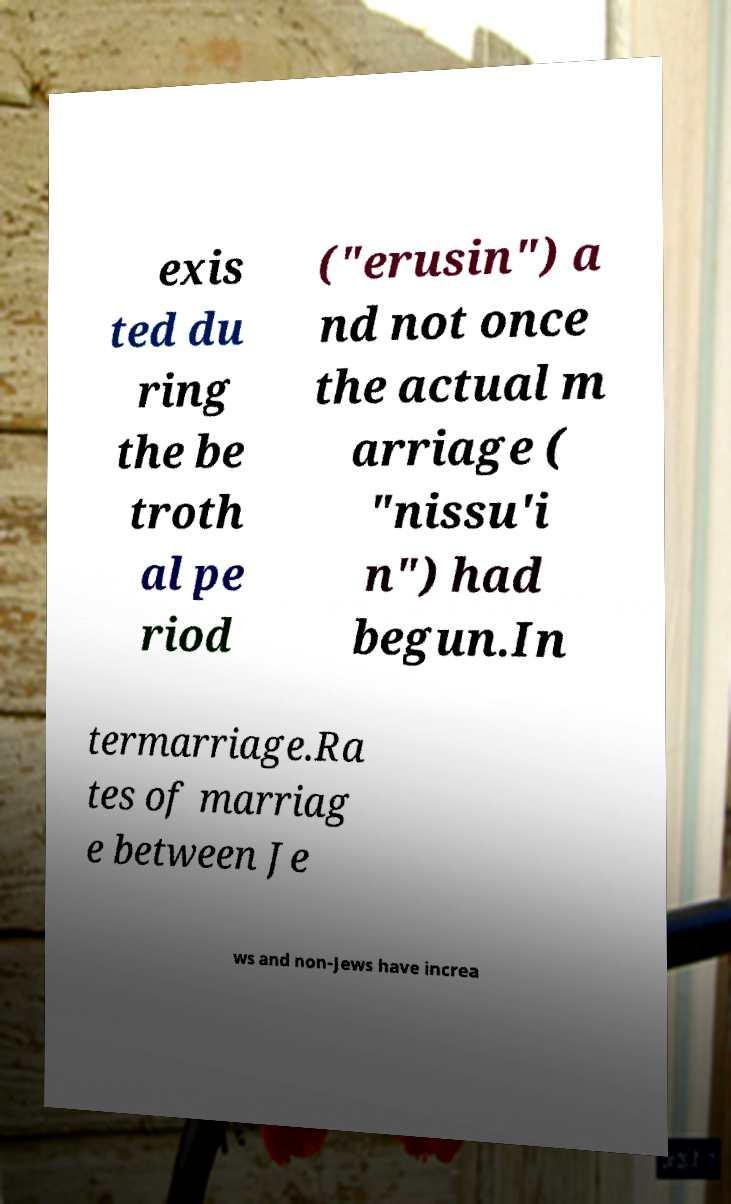I need the written content from this picture converted into text. Can you do that? exis ted du ring the be troth al pe riod ("erusin") a nd not once the actual m arriage ( "nissu'i n") had begun.In termarriage.Ra tes of marriag e between Je ws and non-Jews have increa 